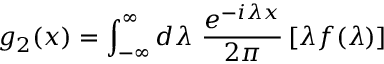Convert formula to latex. <formula><loc_0><loc_0><loc_500><loc_500>g _ { 2 } ( x ) = \int _ { - \infty } ^ { \infty } d \lambda \frac { e ^ { - i \lambda x } } { 2 \pi } \, [ \lambda f ( \lambda ) ]</formula> 